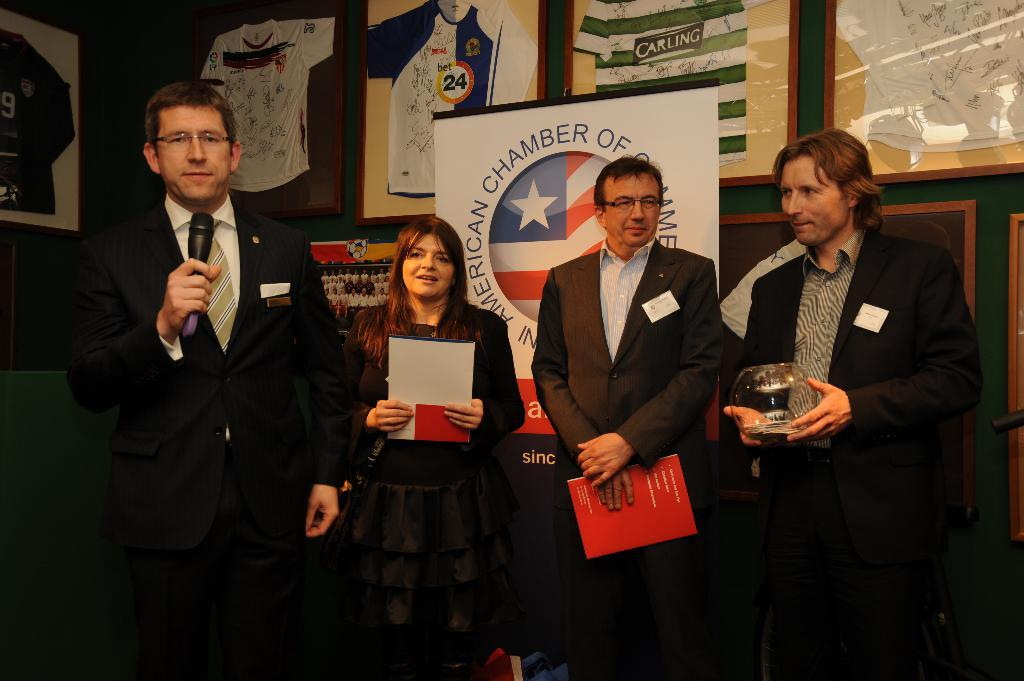Who or what can be seen in the image? There are people in the image. What are the people holding in their hands? The people are holding something in their hands. What can be seen on the wall in the background of the image? There are photo frames on the wall in the background of the image. What town is the guide showing to the grandfather in the image? There is no town, guide, or grandfather present in the image. 